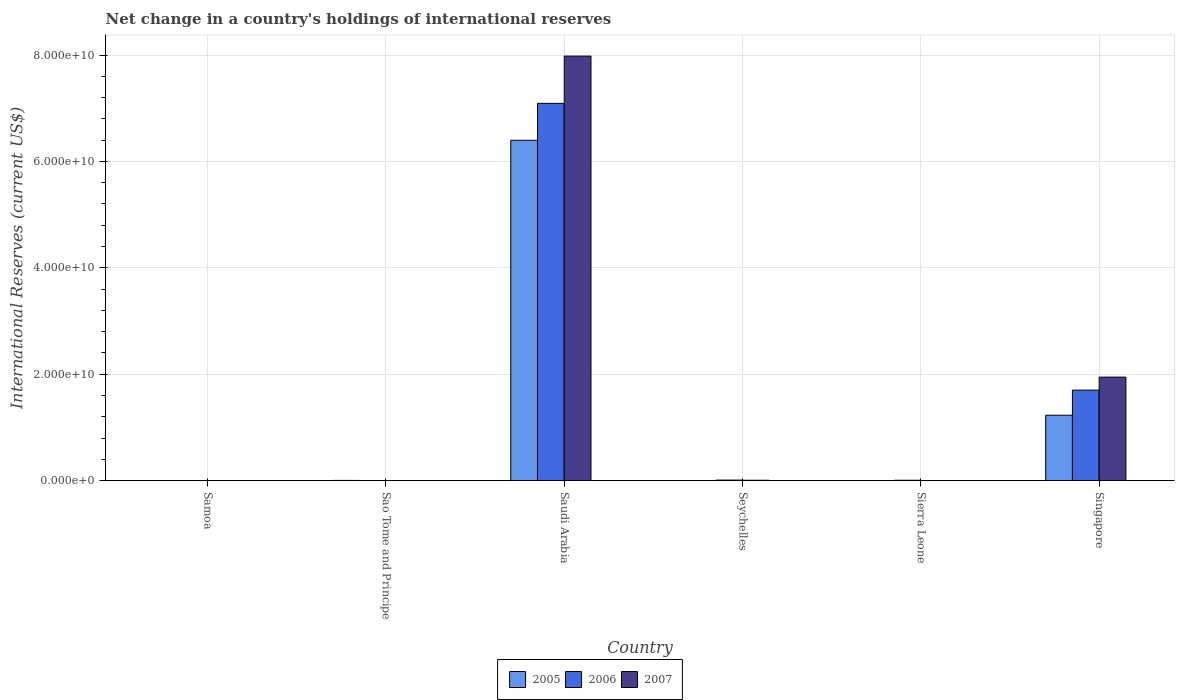Are the number of bars per tick equal to the number of legend labels?
Your response must be concise. No. Are the number of bars on each tick of the X-axis equal?
Give a very brief answer. No. What is the label of the 6th group of bars from the left?
Provide a short and direct response. Singapore. What is the international reserves in 2006 in Singapore?
Your answer should be very brief. 1.70e+1. Across all countries, what is the maximum international reserves in 2006?
Ensure brevity in your answer.  7.09e+1. In which country was the international reserves in 2007 maximum?
Your response must be concise. Saudi Arabia. What is the total international reserves in 2005 in the graph?
Your answer should be compact. 7.63e+1. What is the difference between the international reserves in 2006 in Sao Tome and Principe and that in Seychelles?
Provide a succinct answer. -9.31e+07. What is the difference between the international reserves in 2005 in Singapore and the international reserves in 2007 in Seychelles?
Provide a succinct answer. 1.22e+1. What is the average international reserves in 2006 per country?
Your response must be concise. 1.47e+1. What is the difference between the international reserves of/in 2005 and international reserves of/in 2007 in Singapore?
Provide a succinct answer. -7.16e+09. What is the ratio of the international reserves in 2006 in Sao Tome and Principe to that in Saudi Arabia?
Offer a very short reply. 1.564299031309122e-6. What is the difference between the highest and the second highest international reserves in 2007?
Give a very brief answer. -7.97e+1. What is the difference between the highest and the lowest international reserves in 2006?
Offer a terse response. 7.09e+1. In how many countries, is the international reserves in 2005 greater than the average international reserves in 2005 taken over all countries?
Make the answer very short. 1. Are all the bars in the graph horizontal?
Keep it short and to the point. No. How many countries are there in the graph?
Provide a succinct answer. 6. What is the difference between two consecutive major ticks on the Y-axis?
Your answer should be very brief. 2.00e+1. Does the graph contain grids?
Provide a short and direct response. Yes. Where does the legend appear in the graph?
Your response must be concise. Bottom center. How many legend labels are there?
Provide a short and direct response. 3. What is the title of the graph?
Your answer should be compact. Net change in a country's holdings of international reserves. What is the label or title of the Y-axis?
Ensure brevity in your answer.  International Reserves (current US$). What is the International Reserves (current US$) in 2005 in Samoa?
Keep it short and to the point. 0. What is the International Reserves (current US$) of 2006 in Samoa?
Your response must be concise. 0. What is the International Reserves (current US$) of 2007 in Samoa?
Your response must be concise. 0. What is the International Reserves (current US$) of 2005 in Sao Tome and Principe?
Your response must be concise. 3.05e+07. What is the International Reserves (current US$) of 2006 in Sao Tome and Principe?
Provide a succinct answer. 1.11e+05. What is the International Reserves (current US$) of 2007 in Sao Tome and Principe?
Offer a terse response. 0. What is the International Reserves (current US$) of 2005 in Saudi Arabia?
Your answer should be compact. 6.40e+1. What is the International Reserves (current US$) of 2006 in Saudi Arabia?
Provide a succinct answer. 7.09e+1. What is the International Reserves (current US$) of 2007 in Saudi Arabia?
Provide a short and direct response. 7.98e+1. What is the International Reserves (current US$) in 2006 in Seychelles?
Give a very brief answer. 9.32e+07. What is the International Reserves (current US$) of 2007 in Seychelles?
Your answer should be compact. 6.12e+07. What is the International Reserves (current US$) of 2005 in Sierra Leone?
Provide a succinct answer. 0. What is the International Reserves (current US$) of 2006 in Sierra Leone?
Make the answer very short. 6.04e+07. What is the International Reserves (current US$) in 2007 in Sierra Leone?
Provide a short and direct response. 0. What is the International Reserves (current US$) of 2005 in Singapore?
Your answer should be very brief. 1.23e+1. What is the International Reserves (current US$) of 2006 in Singapore?
Offer a terse response. 1.70e+1. What is the International Reserves (current US$) of 2007 in Singapore?
Ensure brevity in your answer.  1.94e+1. Across all countries, what is the maximum International Reserves (current US$) of 2005?
Ensure brevity in your answer.  6.40e+1. Across all countries, what is the maximum International Reserves (current US$) in 2006?
Your response must be concise. 7.09e+1. Across all countries, what is the maximum International Reserves (current US$) of 2007?
Keep it short and to the point. 7.98e+1. Across all countries, what is the minimum International Reserves (current US$) of 2007?
Give a very brief answer. 0. What is the total International Reserves (current US$) of 2005 in the graph?
Your answer should be compact. 7.63e+1. What is the total International Reserves (current US$) of 2006 in the graph?
Keep it short and to the point. 8.81e+1. What is the total International Reserves (current US$) in 2007 in the graph?
Ensure brevity in your answer.  9.93e+1. What is the difference between the International Reserves (current US$) in 2005 in Sao Tome and Principe and that in Saudi Arabia?
Provide a succinct answer. -6.39e+1. What is the difference between the International Reserves (current US$) in 2006 in Sao Tome and Principe and that in Saudi Arabia?
Keep it short and to the point. -7.09e+1. What is the difference between the International Reserves (current US$) in 2006 in Sao Tome and Principe and that in Seychelles?
Your response must be concise. -9.31e+07. What is the difference between the International Reserves (current US$) in 2006 in Sao Tome and Principe and that in Sierra Leone?
Offer a terse response. -6.02e+07. What is the difference between the International Reserves (current US$) in 2005 in Sao Tome and Principe and that in Singapore?
Your response must be concise. -1.23e+1. What is the difference between the International Reserves (current US$) in 2006 in Sao Tome and Principe and that in Singapore?
Make the answer very short. -1.70e+1. What is the difference between the International Reserves (current US$) in 2006 in Saudi Arabia and that in Seychelles?
Make the answer very short. 7.08e+1. What is the difference between the International Reserves (current US$) in 2007 in Saudi Arabia and that in Seychelles?
Your answer should be very brief. 7.97e+1. What is the difference between the International Reserves (current US$) of 2006 in Saudi Arabia and that in Sierra Leone?
Provide a succinct answer. 7.08e+1. What is the difference between the International Reserves (current US$) in 2005 in Saudi Arabia and that in Singapore?
Ensure brevity in your answer.  5.17e+1. What is the difference between the International Reserves (current US$) of 2006 in Saudi Arabia and that in Singapore?
Offer a very short reply. 5.39e+1. What is the difference between the International Reserves (current US$) in 2007 in Saudi Arabia and that in Singapore?
Give a very brief answer. 6.03e+1. What is the difference between the International Reserves (current US$) of 2006 in Seychelles and that in Sierra Leone?
Give a very brief answer. 3.29e+07. What is the difference between the International Reserves (current US$) in 2006 in Seychelles and that in Singapore?
Provide a succinct answer. -1.69e+1. What is the difference between the International Reserves (current US$) in 2007 in Seychelles and that in Singapore?
Ensure brevity in your answer.  -1.94e+1. What is the difference between the International Reserves (current US$) of 2006 in Sierra Leone and that in Singapore?
Offer a terse response. -1.69e+1. What is the difference between the International Reserves (current US$) of 2005 in Sao Tome and Principe and the International Reserves (current US$) of 2006 in Saudi Arabia?
Your answer should be compact. -7.09e+1. What is the difference between the International Reserves (current US$) of 2005 in Sao Tome and Principe and the International Reserves (current US$) of 2007 in Saudi Arabia?
Keep it short and to the point. -7.98e+1. What is the difference between the International Reserves (current US$) of 2006 in Sao Tome and Principe and the International Reserves (current US$) of 2007 in Saudi Arabia?
Your response must be concise. -7.98e+1. What is the difference between the International Reserves (current US$) in 2005 in Sao Tome and Principe and the International Reserves (current US$) in 2006 in Seychelles?
Your answer should be compact. -6.27e+07. What is the difference between the International Reserves (current US$) of 2005 in Sao Tome and Principe and the International Reserves (current US$) of 2007 in Seychelles?
Your response must be concise. -3.07e+07. What is the difference between the International Reserves (current US$) in 2006 in Sao Tome and Principe and the International Reserves (current US$) in 2007 in Seychelles?
Your response must be concise. -6.11e+07. What is the difference between the International Reserves (current US$) of 2005 in Sao Tome and Principe and the International Reserves (current US$) of 2006 in Sierra Leone?
Make the answer very short. -2.98e+07. What is the difference between the International Reserves (current US$) of 2005 in Sao Tome and Principe and the International Reserves (current US$) of 2006 in Singapore?
Your response must be concise. -1.70e+1. What is the difference between the International Reserves (current US$) in 2005 in Sao Tome and Principe and the International Reserves (current US$) in 2007 in Singapore?
Keep it short and to the point. -1.94e+1. What is the difference between the International Reserves (current US$) of 2006 in Sao Tome and Principe and the International Reserves (current US$) of 2007 in Singapore?
Provide a short and direct response. -1.94e+1. What is the difference between the International Reserves (current US$) in 2005 in Saudi Arabia and the International Reserves (current US$) in 2006 in Seychelles?
Offer a terse response. 6.39e+1. What is the difference between the International Reserves (current US$) in 2005 in Saudi Arabia and the International Reserves (current US$) in 2007 in Seychelles?
Give a very brief answer. 6.39e+1. What is the difference between the International Reserves (current US$) in 2006 in Saudi Arabia and the International Reserves (current US$) in 2007 in Seychelles?
Your answer should be very brief. 7.08e+1. What is the difference between the International Reserves (current US$) in 2005 in Saudi Arabia and the International Reserves (current US$) in 2006 in Sierra Leone?
Ensure brevity in your answer.  6.39e+1. What is the difference between the International Reserves (current US$) in 2005 in Saudi Arabia and the International Reserves (current US$) in 2006 in Singapore?
Your answer should be very brief. 4.70e+1. What is the difference between the International Reserves (current US$) of 2005 in Saudi Arabia and the International Reserves (current US$) of 2007 in Singapore?
Give a very brief answer. 4.45e+1. What is the difference between the International Reserves (current US$) of 2006 in Saudi Arabia and the International Reserves (current US$) of 2007 in Singapore?
Give a very brief answer. 5.15e+1. What is the difference between the International Reserves (current US$) of 2006 in Seychelles and the International Reserves (current US$) of 2007 in Singapore?
Give a very brief answer. -1.94e+1. What is the difference between the International Reserves (current US$) in 2006 in Sierra Leone and the International Reserves (current US$) in 2007 in Singapore?
Ensure brevity in your answer.  -1.94e+1. What is the average International Reserves (current US$) in 2005 per country?
Give a very brief answer. 1.27e+1. What is the average International Reserves (current US$) of 2006 per country?
Your answer should be very brief. 1.47e+1. What is the average International Reserves (current US$) in 2007 per country?
Give a very brief answer. 1.66e+1. What is the difference between the International Reserves (current US$) of 2005 and International Reserves (current US$) of 2006 in Sao Tome and Principe?
Ensure brevity in your answer.  3.04e+07. What is the difference between the International Reserves (current US$) of 2005 and International Reserves (current US$) of 2006 in Saudi Arabia?
Keep it short and to the point. -6.94e+09. What is the difference between the International Reserves (current US$) in 2005 and International Reserves (current US$) in 2007 in Saudi Arabia?
Your answer should be compact. -1.58e+1. What is the difference between the International Reserves (current US$) in 2006 and International Reserves (current US$) in 2007 in Saudi Arabia?
Offer a terse response. -8.88e+09. What is the difference between the International Reserves (current US$) in 2006 and International Reserves (current US$) in 2007 in Seychelles?
Ensure brevity in your answer.  3.20e+07. What is the difference between the International Reserves (current US$) in 2005 and International Reserves (current US$) in 2006 in Singapore?
Offer a terse response. -4.72e+09. What is the difference between the International Reserves (current US$) of 2005 and International Reserves (current US$) of 2007 in Singapore?
Provide a succinct answer. -7.16e+09. What is the difference between the International Reserves (current US$) of 2006 and International Reserves (current US$) of 2007 in Singapore?
Your answer should be very brief. -2.44e+09. What is the ratio of the International Reserves (current US$) of 2006 in Sao Tome and Principe to that in Seychelles?
Offer a terse response. 0. What is the ratio of the International Reserves (current US$) in 2006 in Sao Tome and Principe to that in Sierra Leone?
Ensure brevity in your answer.  0. What is the ratio of the International Reserves (current US$) in 2005 in Sao Tome and Principe to that in Singapore?
Offer a terse response. 0. What is the ratio of the International Reserves (current US$) in 2006 in Sao Tome and Principe to that in Singapore?
Keep it short and to the point. 0. What is the ratio of the International Reserves (current US$) in 2006 in Saudi Arabia to that in Seychelles?
Offer a terse response. 760.58. What is the ratio of the International Reserves (current US$) in 2007 in Saudi Arabia to that in Seychelles?
Make the answer very short. 1302.82. What is the ratio of the International Reserves (current US$) in 2006 in Saudi Arabia to that in Sierra Leone?
Offer a very short reply. 1174.83. What is the ratio of the International Reserves (current US$) in 2005 in Saudi Arabia to that in Singapore?
Keep it short and to the point. 5.21. What is the ratio of the International Reserves (current US$) of 2006 in Saudi Arabia to that in Singapore?
Keep it short and to the point. 4.17. What is the ratio of the International Reserves (current US$) in 2007 in Saudi Arabia to that in Singapore?
Keep it short and to the point. 4.1. What is the ratio of the International Reserves (current US$) in 2006 in Seychelles to that in Sierra Leone?
Provide a succinct answer. 1.54. What is the ratio of the International Reserves (current US$) in 2006 in Seychelles to that in Singapore?
Ensure brevity in your answer.  0.01. What is the ratio of the International Reserves (current US$) of 2007 in Seychelles to that in Singapore?
Provide a short and direct response. 0. What is the ratio of the International Reserves (current US$) of 2006 in Sierra Leone to that in Singapore?
Offer a terse response. 0. What is the difference between the highest and the second highest International Reserves (current US$) of 2005?
Your answer should be compact. 5.17e+1. What is the difference between the highest and the second highest International Reserves (current US$) in 2006?
Offer a terse response. 5.39e+1. What is the difference between the highest and the second highest International Reserves (current US$) in 2007?
Make the answer very short. 6.03e+1. What is the difference between the highest and the lowest International Reserves (current US$) in 2005?
Your answer should be compact. 6.40e+1. What is the difference between the highest and the lowest International Reserves (current US$) in 2006?
Offer a terse response. 7.09e+1. What is the difference between the highest and the lowest International Reserves (current US$) of 2007?
Keep it short and to the point. 7.98e+1. 